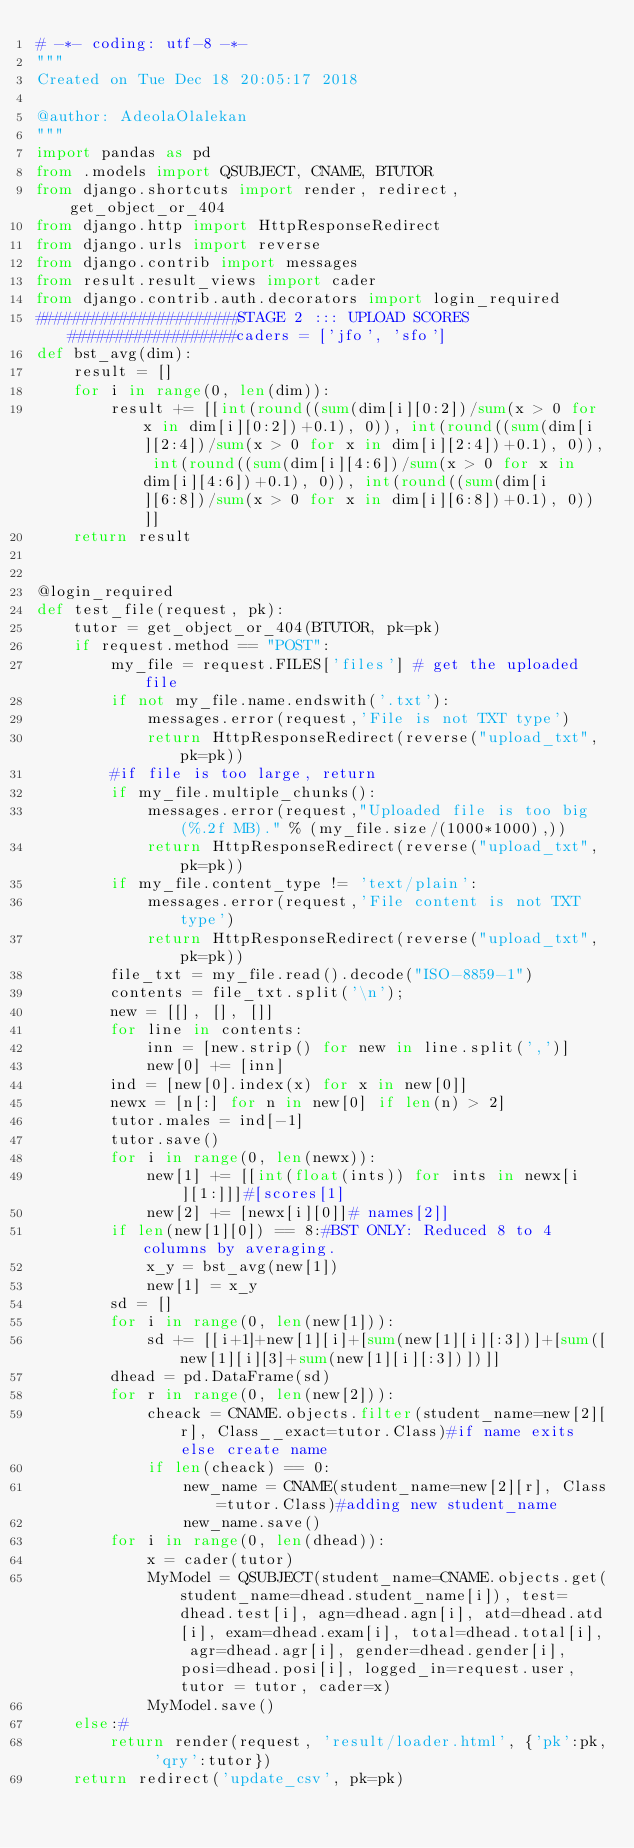Convert code to text. <code><loc_0><loc_0><loc_500><loc_500><_Python_># -*- coding: utf-8 -*-
"""
Created on Tue Dec 18 20:05:17 2018

@author: AdeolaOlalekan
"""
import pandas as pd
from .models import QSUBJECT, CNAME, BTUTOR
from django.shortcuts import render, redirect, get_object_or_404
from django.http import HttpResponseRedirect
from django.urls import reverse
from django.contrib import messages
from result.result_views import cader
from django.contrib.auth.decorators import login_required
######################STAGE 2 ::: UPLOAD SCORES##################caders = ['jfo', 'sfo']
def bst_avg(dim):
    result = []
    for i in range(0, len(dim)):
        result += [[int(round((sum(dim[i][0:2])/sum(x > 0 for x in dim[i][0:2])+0.1), 0)), int(round((sum(dim[i][2:4])/sum(x > 0 for x in dim[i][2:4])+0.1), 0)), int(round((sum(dim[i][4:6])/sum(x > 0 for x in dim[i][4:6])+0.1), 0)), int(round((sum(dim[i][6:8])/sum(x > 0 for x in dim[i][6:8])+0.1), 0))]]
    return result 


@login_required
def test_file(request, pk):
    tutor = get_object_or_404(BTUTOR, pk=pk) 
    if request.method == "POST":
        my_file = request.FILES['files'] # get the uploaded file
        if not my_file.name.endswith('.txt'):
            messages.error(request,'File is not TXT type')
            return HttpResponseRedirect(reverse("upload_txt", pk=pk))
        #if file is too large, return
        if my_file.multiple_chunks():
            messages.error(request,"Uploaded file is too big (%.2f MB)." % (my_file.size/(1000*1000),))
            return HttpResponseRedirect(reverse("upload_txt", pk=pk))
        if my_file.content_type != 'text/plain':
            messages.error(request,'File content is not TXT type')
            return HttpResponseRedirect(reverse("upload_txt", pk=pk))
        file_txt = my_file.read().decode("ISO-8859-1")
        contents = file_txt.split('\n');
        new = [[], [], []]
        for line in contents:
            inn = [new.strip() for new in line.split(',')]
            new[0] += [inn]
        ind = [new[0].index(x) for x in new[0]]
        newx = [n[:] for n in new[0] if len(n) > 2]
        tutor.males = ind[-1]
        tutor.save()
        for i in range(0, len(newx)):
            new[1] += [[int(float(ints)) for ints in newx[i][1:]]]#[scores[1]
            new[2] += [newx[i][0]]# names[2]]
        if len(new[1][0]) == 8:#BST ONLY: Reduced 8 to 4 columns by averaging.
            x_y = bst_avg(new[1])
            new[1] = x_y
        sd = []
        for i in range(0, len(new[1])):
            sd += [[i+1]+new[1][i]+[sum(new[1][i][:3])]+[sum([new[1][i][3]+sum(new[1][i][:3])])]]
        dhead = pd.DataFrame(sd)
        for r in range(0, len(new[2])):
            cheack = CNAME.objects.filter(student_name=new[2][r], Class__exact=tutor.Class)#if name exits else create name
            if len(cheack) == 0:
                new_name = CNAME(student_name=new[2][r], Class=tutor.Class)#adding new student_name
                new_name.save()
        for i in range(0, len(dhead)):
            x = cader(tutor)
            MyModel = QSUBJECT(student_name=CNAME.objects.get(student_name=dhead.student_name[i]), test=dhead.test[i], agn=dhead.agn[i], atd=dhead.atd[i], exam=dhead.exam[i], total=dhead.total[i], agr=dhead.agr[i], gender=dhead.gender[i], posi=dhead.posi[i], logged_in=request.user, tutor = tutor, cader=x)
            MyModel.save() 
    else:#
        return render(request, 'result/loader.html', {'pk':pk, 'qry':tutor})
    return redirect('update_csv', pk=pk)

 
</code> 